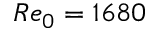Convert formula to latex. <formula><loc_0><loc_0><loc_500><loc_500>R e _ { 0 } = 1 6 8 0</formula> 